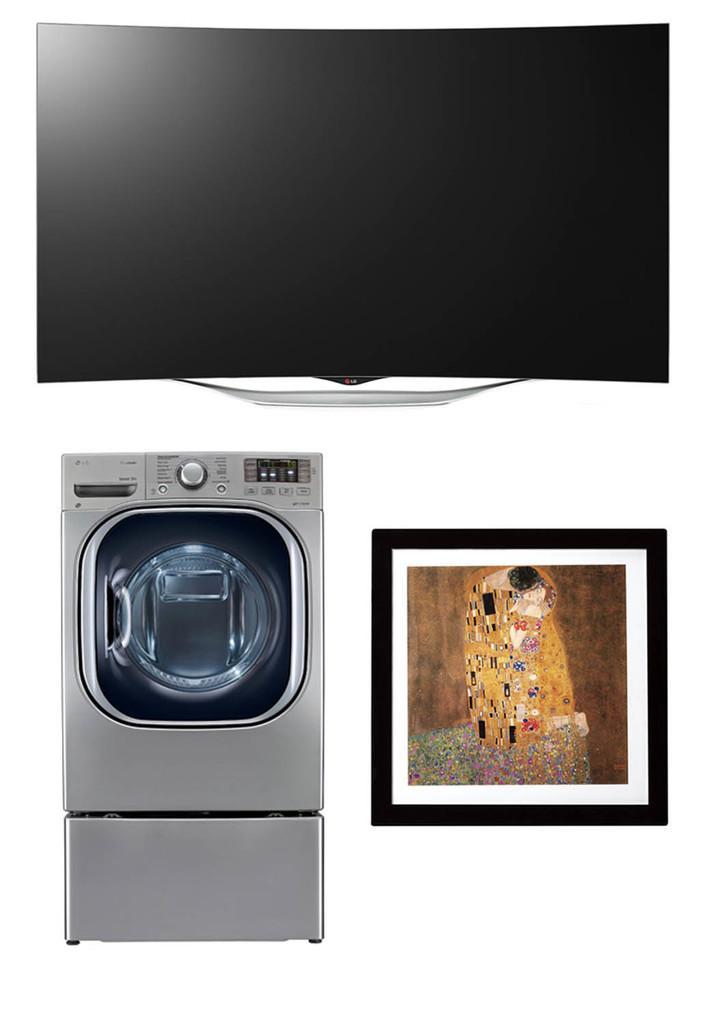Please provide a concise description of this image. In the image we can see there is a LED tv, washing machine and a photo frame. 